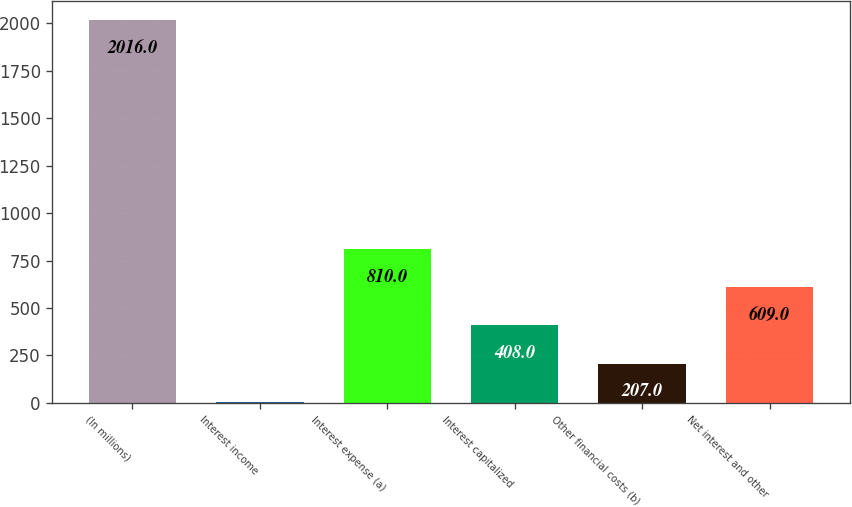<chart> <loc_0><loc_0><loc_500><loc_500><bar_chart><fcel>(In millions)<fcel>Interest income<fcel>Interest expense (a)<fcel>Interest capitalized<fcel>Other financial costs (b)<fcel>Net interest and other<nl><fcel>2016<fcel>6<fcel>810<fcel>408<fcel>207<fcel>609<nl></chart> 